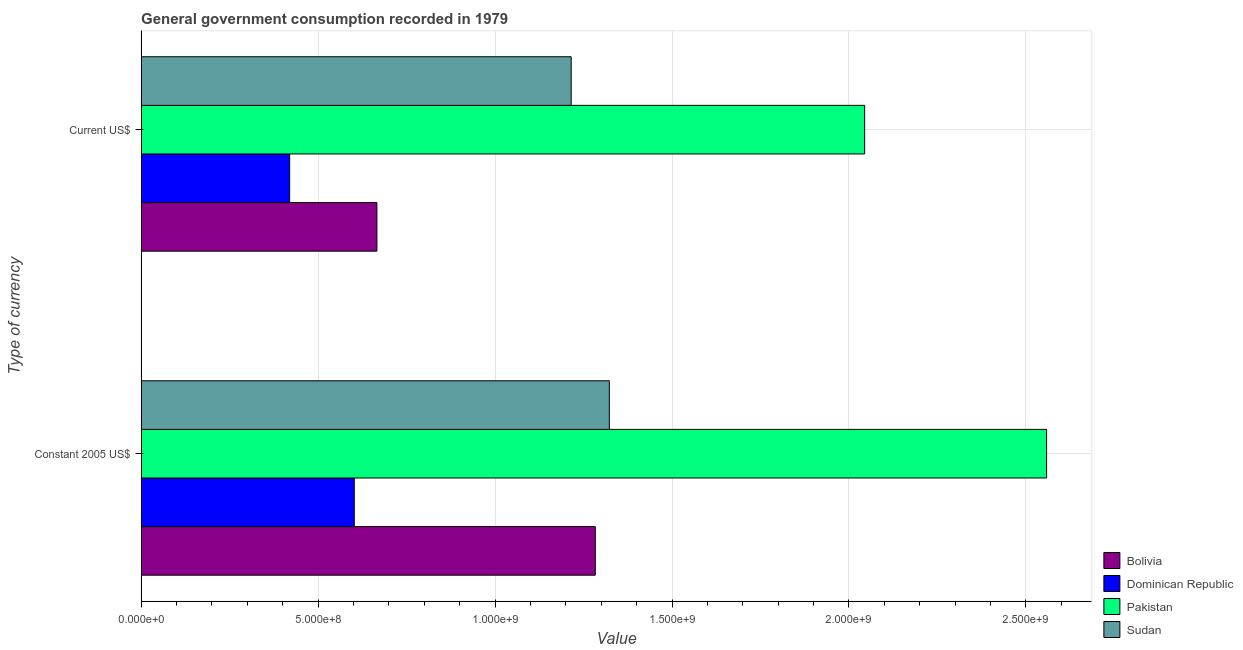How many groups of bars are there?
Provide a succinct answer. 2. How many bars are there on the 2nd tick from the top?
Your response must be concise. 4. How many bars are there on the 1st tick from the bottom?
Your response must be concise. 4. What is the label of the 1st group of bars from the top?
Give a very brief answer. Current US$. What is the value consumed in current us$ in Dominican Republic?
Your response must be concise. 4.20e+08. Across all countries, what is the maximum value consumed in current us$?
Your answer should be very brief. 2.04e+09. Across all countries, what is the minimum value consumed in constant 2005 us$?
Keep it short and to the point. 6.02e+08. In which country was the value consumed in current us$ minimum?
Your answer should be compact. Dominican Republic. What is the total value consumed in current us$ in the graph?
Your response must be concise. 4.35e+09. What is the difference between the value consumed in constant 2005 us$ in Sudan and that in Dominican Republic?
Your response must be concise. 7.21e+08. What is the difference between the value consumed in constant 2005 us$ in Sudan and the value consumed in current us$ in Dominican Republic?
Make the answer very short. 9.03e+08. What is the average value consumed in current us$ per country?
Offer a terse response. 1.09e+09. What is the difference between the value consumed in current us$ and value consumed in constant 2005 us$ in Bolivia?
Your answer should be very brief. -6.17e+08. In how many countries, is the value consumed in constant 2005 us$ greater than 300000000 ?
Provide a succinct answer. 4. What is the ratio of the value consumed in constant 2005 us$ in Bolivia to that in Pakistan?
Your answer should be very brief. 0.5. Is the value consumed in constant 2005 us$ in Dominican Republic less than that in Pakistan?
Offer a terse response. Yes. What does the 2nd bar from the top in Current US$ represents?
Provide a short and direct response. Pakistan. What does the 2nd bar from the bottom in Constant 2005 US$ represents?
Your response must be concise. Dominican Republic. How many bars are there?
Your answer should be compact. 8. Are all the bars in the graph horizontal?
Your answer should be compact. Yes. What is the difference between two consecutive major ticks on the X-axis?
Provide a short and direct response. 5.00e+08. Are the values on the major ticks of X-axis written in scientific E-notation?
Give a very brief answer. Yes. Does the graph contain any zero values?
Your response must be concise. No. Does the graph contain grids?
Offer a very short reply. Yes. Where does the legend appear in the graph?
Make the answer very short. Bottom right. What is the title of the graph?
Give a very brief answer. General government consumption recorded in 1979. What is the label or title of the X-axis?
Offer a terse response. Value. What is the label or title of the Y-axis?
Ensure brevity in your answer.  Type of currency. What is the Value in Bolivia in Constant 2005 US$?
Ensure brevity in your answer.  1.28e+09. What is the Value in Dominican Republic in Constant 2005 US$?
Offer a terse response. 6.02e+08. What is the Value in Pakistan in Constant 2005 US$?
Offer a very short reply. 2.56e+09. What is the Value of Sudan in Constant 2005 US$?
Offer a very short reply. 1.32e+09. What is the Value in Bolivia in Current US$?
Your response must be concise. 6.66e+08. What is the Value of Dominican Republic in Current US$?
Ensure brevity in your answer.  4.20e+08. What is the Value of Pakistan in Current US$?
Your answer should be very brief. 2.04e+09. What is the Value of Sudan in Current US$?
Give a very brief answer. 1.22e+09. Across all Type of currency, what is the maximum Value of Bolivia?
Your answer should be compact. 1.28e+09. Across all Type of currency, what is the maximum Value of Dominican Republic?
Make the answer very short. 6.02e+08. Across all Type of currency, what is the maximum Value of Pakistan?
Give a very brief answer. 2.56e+09. Across all Type of currency, what is the maximum Value in Sudan?
Your answer should be compact. 1.32e+09. Across all Type of currency, what is the minimum Value in Bolivia?
Provide a succinct answer. 6.66e+08. Across all Type of currency, what is the minimum Value in Dominican Republic?
Offer a very short reply. 4.20e+08. Across all Type of currency, what is the minimum Value in Pakistan?
Your answer should be very brief. 2.04e+09. Across all Type of currency, what is the minimum Value of Sudan?
Your answer should be compact. 1.22e+09. What is the total Value in Bolivia in the graph?
Offer a terse response. 1.95e+09. What is the total Value in Dominican Republic in the graph?
Provide a short and direct response. 1.02e+09. What is the total Value in Pakistan in the graph?
Your answer should be compact. 4.60e+09. What is the total Value in Sudan in the graph?
Give a very brief answer. 2.54e+09. What is the difference between the Value of Bolivia in Constant 2005 US$ and that in Current US$?
Your answer should be compact. 6.17e+08. What is the difference between the Value in Dominican Republic in Constant 2005 US$ and that in Current US$?
Offer a very short reply. 1.83e+08. What is the difference between the Value of Pakistan in Constant 2005 US$ and that in Current US$?
Your response must be concise. 5.14e+08. What is the difference between the Value of Sudan in Constant 2005 US$ and that in Current US$?
Your answer should be very brief. 1.08e+08. What is the difference between the Value of Bolivia in Constant 2005 US$ and the Value of Dominican Republic in Current US$?
Provide a short and direct response. 8.64e+08. What is the difference between the Value in Bolivia in Constant 2005 US$ and the Value in Pakistan in Current US$?
Offer a terse response. -7.61e+08. What is the difference between the Value in Bolivia in Constant 2005 US$ and the Value in Sudan in Current US$?
Give a very brief answer. 6.81e+07. What is the difference between the Value of Dominican Republic in Constant 2005 US$ and the Value of Pakistan in Current US$?
Your answer should be very brief. -1.44e+09. What is the difference between the Value in Dominican Republic in Constant 2005 US$ and the Value in Sudan in Current US$?
Provide a short and direct response. -6.13e+08. What is the difference between the Value of Pakistan in Constant 2005 US$ and the Value of Sudan in Current US$?
Give a very brief answer. 1.34e+09. What is the average Value in Bolivia per Type of currency?
Offer a terse response. 9.75e+08. What is the average Value of Dominican Republic per Type of currency?
Offer a very short reply. 5.11e+08. What is the average Value of Pakistan per Type of currency?
Ensure brevity in your answer.  2.30e+09. What is the average Value of Sudan per Type of currency?
Give a very brief answer. 1.27e+09. What is the difference between the Value in Bolivia and Value in Dominican Republic in Constant 2005 US$?
Provide a short and direct response. 6.81e+08. What is the difference between the Value of Bolivia and Value of Pakistan in Constant 2005 US$?
Offer a very short reply. -1.28e+09. What is the difference between the Value in Bolivia and Value in Sudan in Constant 2005 US$?
Your answer should be compact. -3.96e+07. What is the difference between the Value in Dominican Republic and Value in Pakistan in Constant 2005 US$?
Make the answer very short. -1.96e+09. What is the difference between the Value in Dominican Republic and Value in Sudan in Constant 2005 US$?
Your response must be concise. -7.21e+08. What is the difference between the Value in Pakistan and Value in Sudan in Constant 2005 US$?
Provide a short and direct response. 1.24e+09. What is the difference between the Value of Bolivia and Value of Dominican Republic in Current US$?
Make the answer very short. 2.47e+08. What is the difference between the Value in Bolivia and Value in Pakistan in Current US$?
Your answer should be compact. -1.38e+09. What is the difference between the Value of Bolivia and Value of Sudan in Current US$?
Make the answer very short. -5.49e+08. What is the difference between the Value in Dominican Republic and Value in Pakistan in Current US$?
Provide a short and direct response. -1.62e+09. What is the difference between the Value of Dominican Republic and Value of Sudan in Current US$?
Your answer should be compact. -7.96e+08. What is the difference between the Value of Pakistan and Value of Sudan in Current US$?
Your answer should be very brief. 8.29e+08. What is the ratio of the Value of Bolivia in Constant 2005 US$ to that in Current US$?
Your answer should be very brief. 1.93. What is the ratio of the Value in Dominican Republic in Constant 2005 US$ to that in Current US$?
Your response must be concise. 1.44. What is the ratio of the Value in Pakistan in Constant 2005 US$ to that in Current US$?
Make the answer very short. 1.25. What is the ratio of the Value in Sudan in Constant 2005 US$ to that in Current US$?
Your answer should be very brief. 1.09. What is the difference between the highest and the second highest Value in Bolivia?
Give a very brief answer. 6.17e+08. What is the difference between the highest and the second highest Value in Dominican Republic?
Provide a succinct answer. 1.83e+08. What is the difference between the highest and the second highest Value in Pakistan?
Ensure brevity in your answer.  5.14e+08. What is the difference between the highest and the second highest Value in Sudan?
Your answer should be compact. 1.08e+08. What is the difference between the highest and the lowest Value in Bolivia?
Provide a short and direct response. 6.17e+08. What is the difference between the highest and the lowest Value of Dominican Republic?
Offer a terse response. 1.83e+08. What is the difference between the highest and the lowest Value in Pakistan?
Your answer should be compact. 5.14e+08. What is the difference between the highest and the lowest Value in Sudan?
Keep it short and to the point. 1.08e+08. 